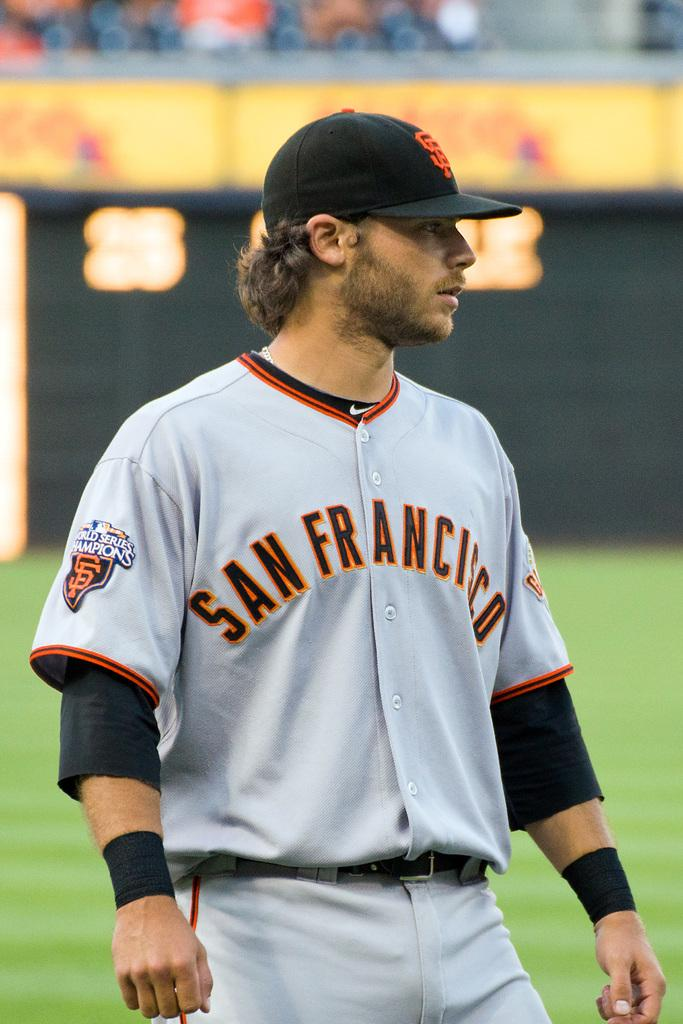Provide a one-sentence caption for the provided image. A man in a uniform that has San Francisco on the front. 